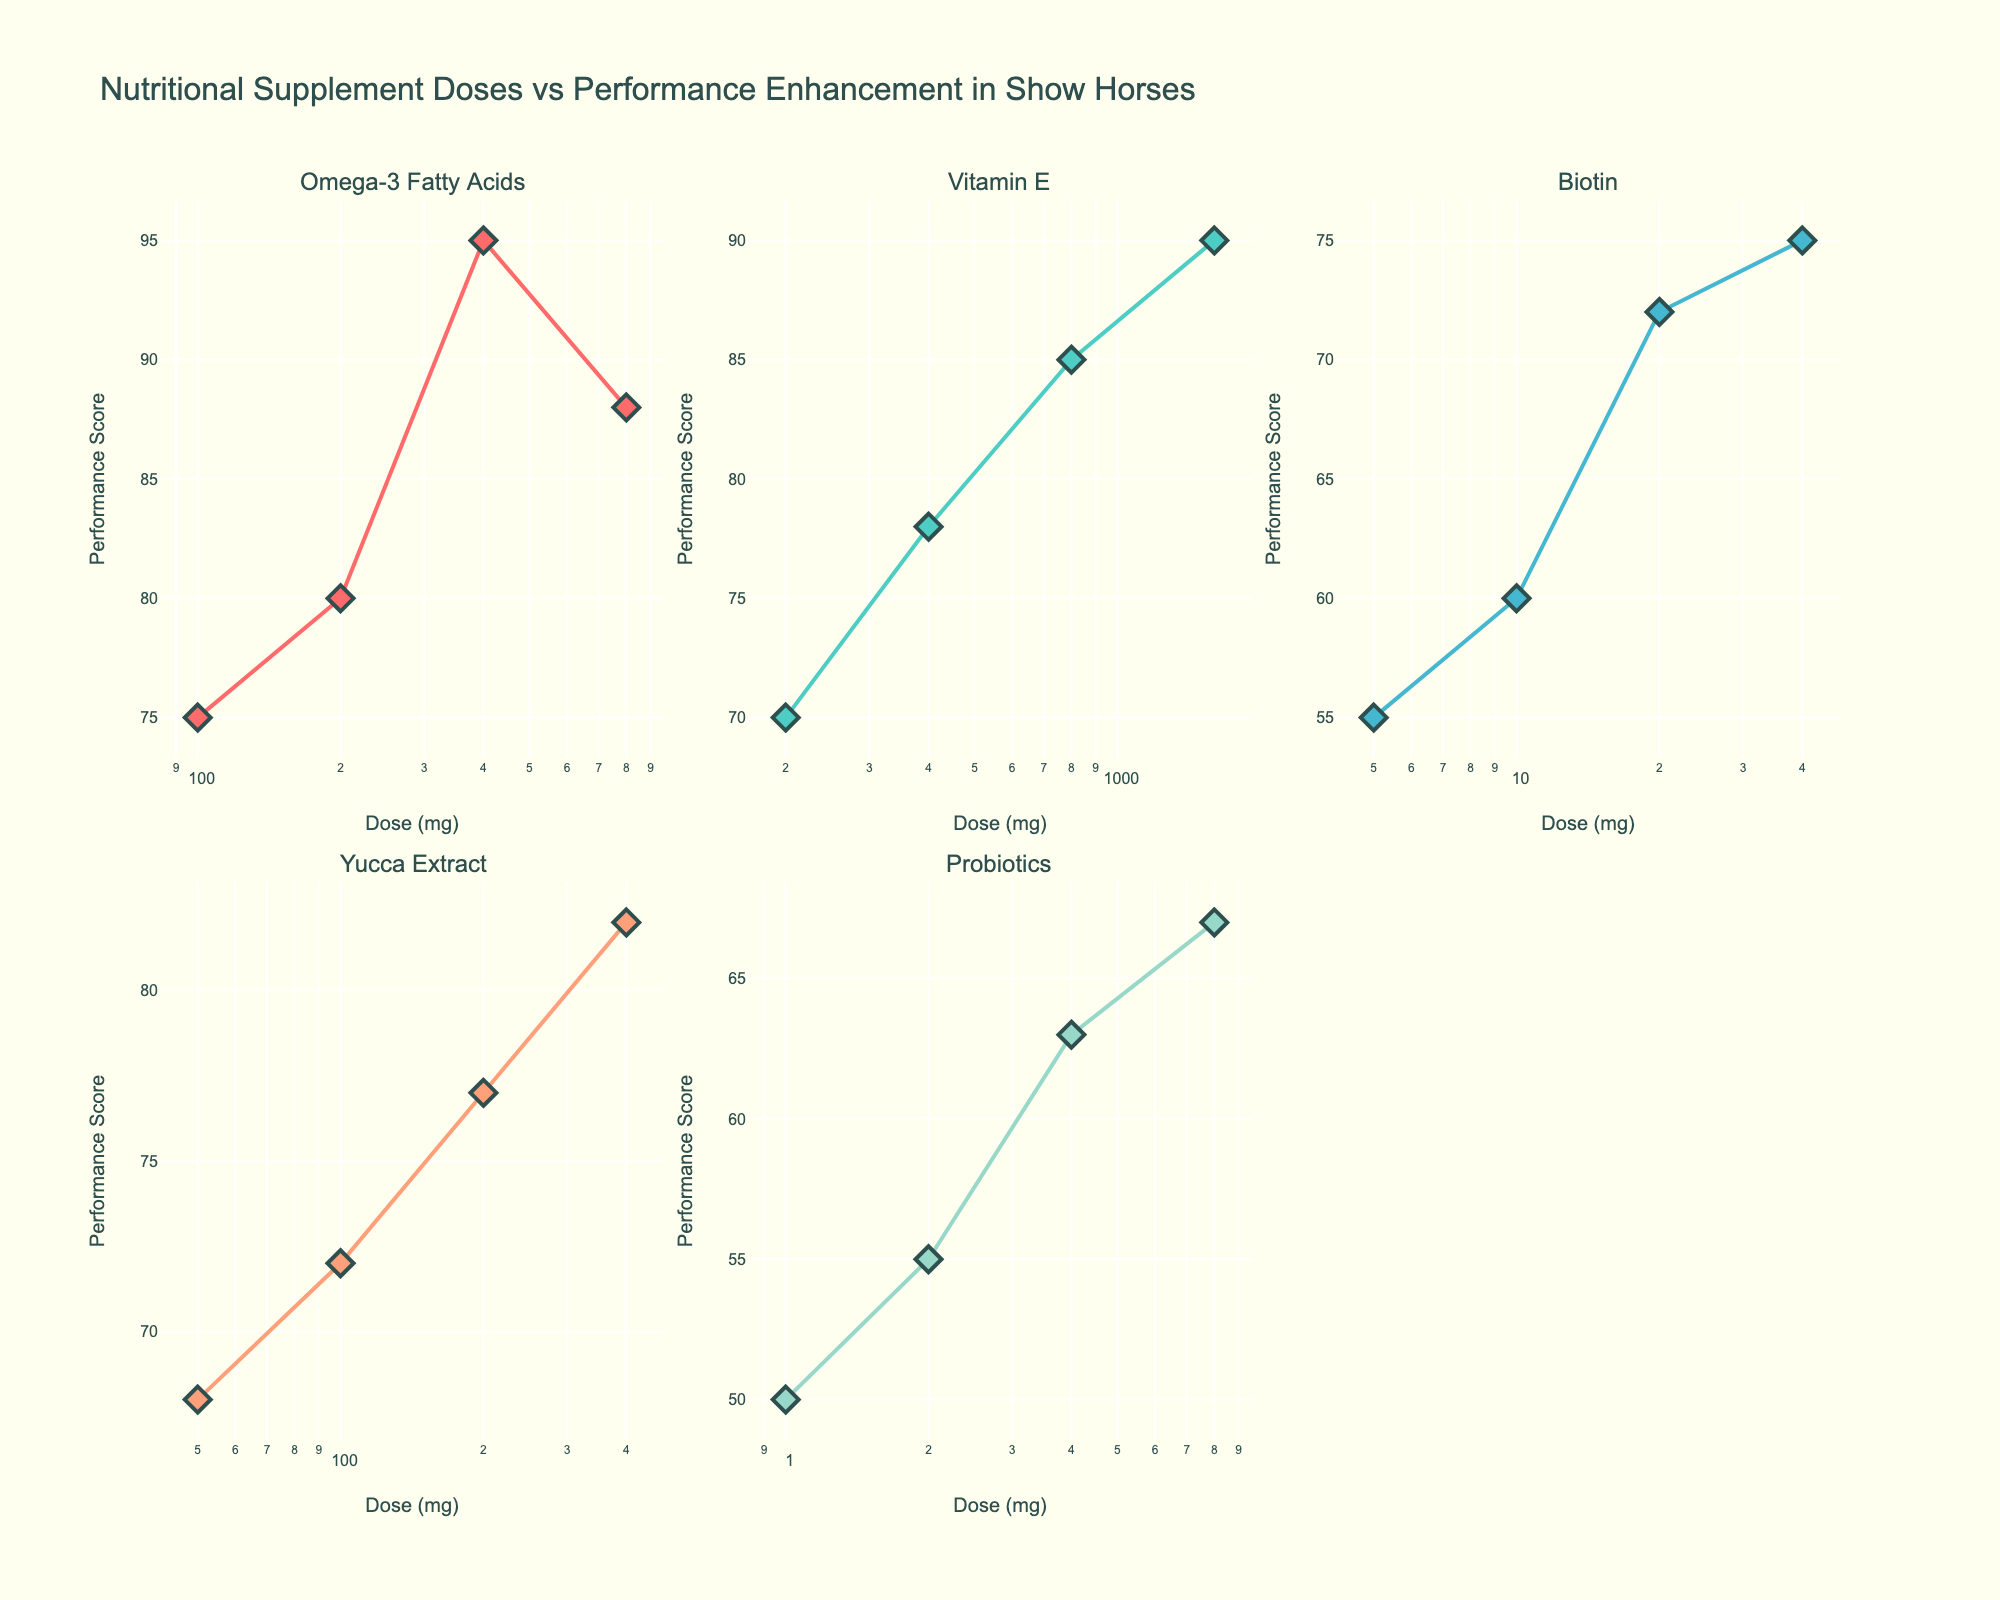Which nutritional supplement shows the highest performance score at its maximum dose? The performance scores can be directly observed for each subplot. Among them, Vitamin E at 1600 mg shows a performance score of 90, which is the highest in the figure.
Answer: Vitamin E What is the dose range for Omega-3 Fatty Acids? By looking at the x-axis of the Omega-3 Fatty Acids subplot, the doses range from 100 mg to 800 mg.
Answer: 100 to 800 mg How does the performance score change for Biotin as the dose increases from 5 mg to 40 mg? For Biotin, observe the plot points on the y-axis as the x-values increase. As the dose increases from 5 mg to 40 mg, the performance score increases from 55 to 75.
Answer: Increases from 55 to 75 Which supplement has the steepest increase in performance score with dose increase? Based on the lines' slopes connecting the data points in each subplot, Omega-3 Fatty Acids shows a noticeable sharp increase from 200 mg to 400 mg (80 to 95).
Answer: Omega-3 Fatty Acids How many supplements were tested in the study? The subplot titles indicate the number of supplements represented. By counting the subplots, we identify there are 5 supplements tested.
Answer: 5 What's the average performance score at the highest dose for all supplements? Determine the highest doses and their corresponding performance scores for each supplement: 
Omega-3 Fatty Acids (88), Vitamin E (90), Biotin (75), Yucca Extract (82), Probiotics (67). Then, calculate the average: (88 + 90 + 75 + 82 + 67) / 5 = 80.4
Answer: 80.4 Which supplement had the smallest increase in performance score with the highest dose? Compare each supplement’s smallest difference in y-values across the highest dose. Probiotics increased from 50 to 67 (smallest increment of 17).
Answer: Probiotics 